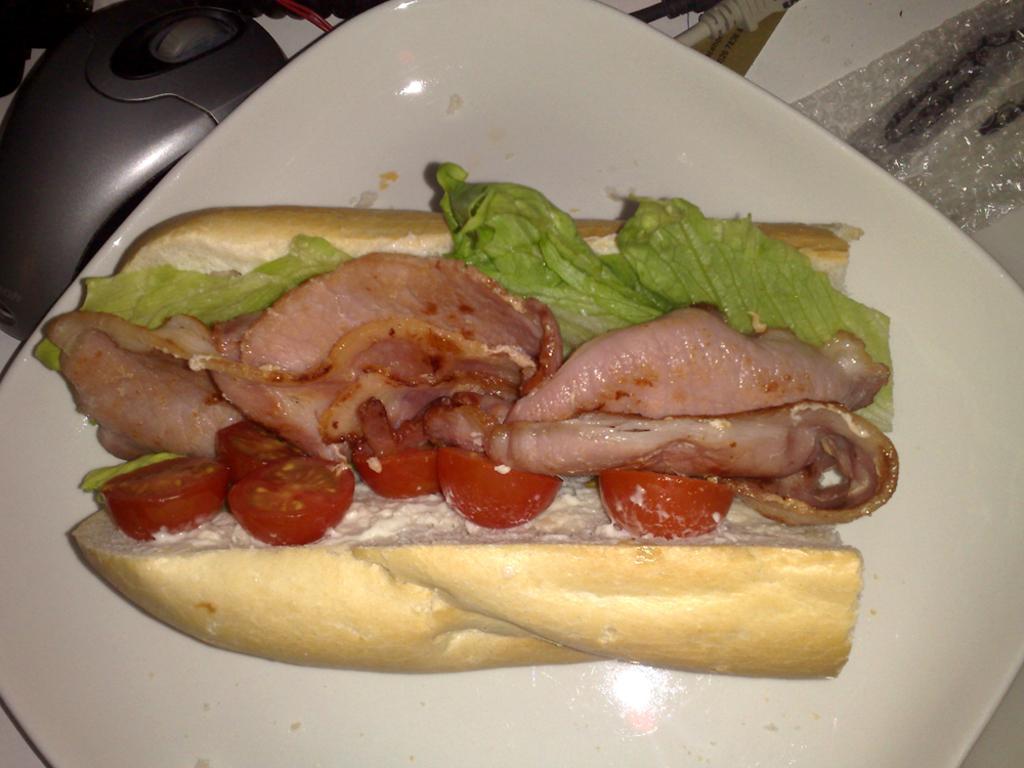Describe this image in one or two sentences. In this picture I can observe some food places in the plate. I can observe meat in the plate. In the top left side I can observe mouse. 